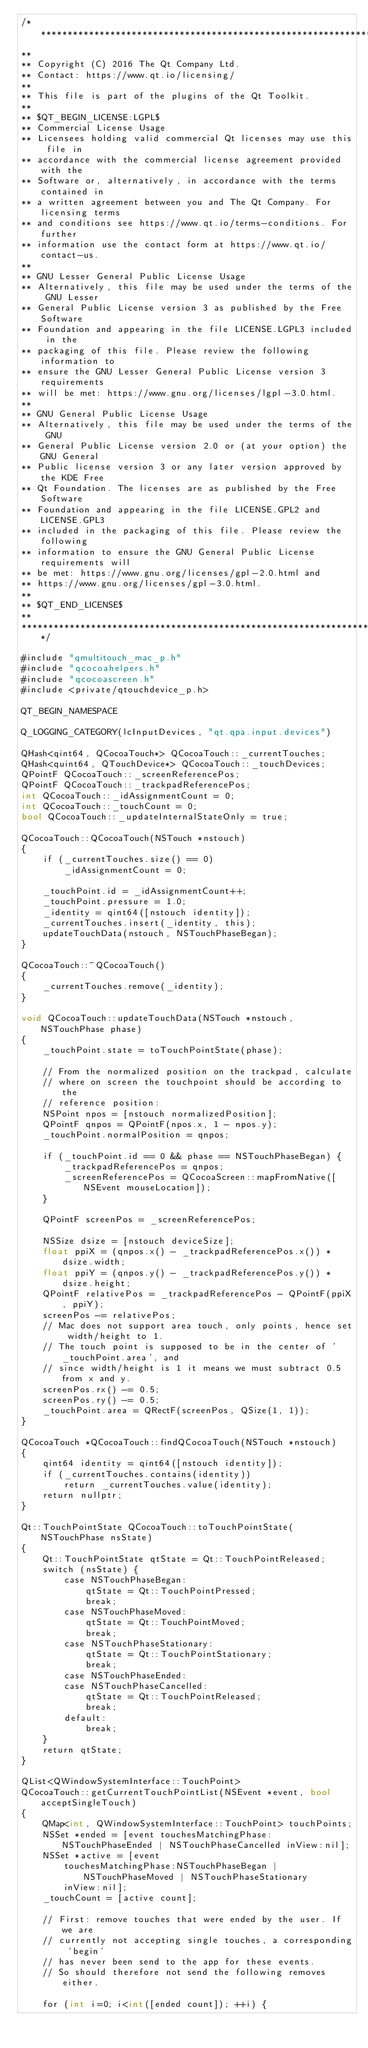<code> <loc_0><loc_0><loc_500><loc_500><_ObjectiveC_>/****************************************************************************
**
** Copyright (C) 2016 The Qt Company Ltd.
** Contact: https://www.qt.io/licensing/
**
** This file is part of the plugins of the Qt Toolkit.
**
** $QT_BEGIN_LICENSE:LGPL$
** Commercial License Usage
** Licensees holding valid commercial Qt licenses may use this file in
** accordance with the commercial license agreement provided with the
** Software or, alternatively, in accordance with the terms contained in
** a written agreement between you and The Qt Company. For licensing terms
** and conditions see https://www.qt.io/terms-conditions. For further
** information use the contact form at https://www.qt.io/contact-us.
**
** GNU Lesser General Public License Usage
** Alternatively, this file may be used under the terms of the GNU Lesser
** General Public License version 3 as published by the Free Software
** Foundation and appearing in the file LICENSE.LGPL3 included in the
** packaging of this file. Please review the following information to
** ensure the GNU Lesser General Public License version 3 requirements
** will be met: https://www.gnu.org/licenses/lgpl-3.0.html.
**
** GNU General Public License Usage
** Alternatively, this file may be used under the terms of the GNU
** General Public License version 2.0 or (at your option) the GNU General
** Public license version 3 or any later version approved by the KDE Free
** Qt Foundation. The licenses are as published by the Free Software
** Foundation and appearing in the file LICENSE.GPL2 and LICENSE.GPL3
** included in the packaging of this file. Please review the following
** information to ensure the GNU General Public License requirements will
** be met: https://www.gnu.org/licenses/gpl-2.0.html and
** https://www.gnu.org/licenses/gpl-3.0.html.
**
** $QT_END_LICENSE$
**
****************************************************************************/

#include "qmultitouch_mac_p.h"
#include "qcocoahelpers.h"
#include "qcocoascreen.h"
#include <private/qtouchdevice_p.h>

QT_BEGIN_NAMESPACE

Q_LOGGING_CATEGORY(lcInputDevices, "qt.qpa.input.devices")

QHash<qint64, QCocoaTouch*> QCocoaTouch::_currentTouches;
QHash<quint64, QTouchDevice*> QCocoaTouch::_touchDevices;
QPointF QCocoaTouch::_screenReferencePos;
QPointF QCocoaTouch::_trackpadReferencePos;
int QCocoaTouch::_idAssignmentCount = 0;
int QCocoaTouch::_touchCount = 0;
bool QCocoaTouch::_updateInternalStateOnly = true;

QCocoaTouch::QCocoaTouch(NSTouch *nstouch)
{
    if (_currentTouches.size() == 0)
        _idAssignmentCount = 0;

    _touchPoint.id = _idAssignmentCount++;
    _touchPoint.pressure = 1.0;
    _identity = qint64([nstouch identity]);
    _currentTouches.insert(_identity, this);
    updateTouchData(nstouch, NSTouchPhaseBegan);
}

QCocoaTouch::~QCocoaTouch()
{
    _currentTouches.remove(_identity);
}

void QCocoaTouch::updateTouchData(NSTouch *nstouch, NSTouchPhase phase)
{
    _touchPoint.state = toTouchPointState(phase);

    // From the normalized position on the trackpad, calculate
    // where on screen the touchpoint should be according to the
    // reference position:
    NSPoint npos = [nstouch normalizedPosition];
    QPointF qnpos = QPointF(npos.x, 1 - npos.y);
    _touchPoint.normalPosition = qnpos;

    if (_touchPoint.id == 0 && phase == NSTouchPhaseBegan) {
        _trackpadReferencePos = qnpos;
        _screenReferencePos = QCocoaScreen::mapFromNative([NSEvent mouseLocation]);
    }

    QPointF screenPos = _screenReferencePos;

    NSSize dsize = [nstouch deviceSize];
    float ppiX = (qnpos.x() - _trackpadReferencePos.x()) * dsize.width;
    float ppiY = (qnpos.y() - _trackpadReferencePos.y()) * dsize.height;
    QPointF relativePos = _trackpadReferencePos - QPointF(ppiX, ppiY);
    screenPos -= relativePos;
    // Mac does not support area touch, only points, hence set width/height to 1.
    // The touch point is supposed to be in the center of '_touchPoint.area', and
    // since width/height is 1 it means we must subtract 0.5 from x and y.
    screenPos.rx() -= 0.5;
    screenPos.ry() -= 0.5;
    _touchPoint.area = QRectF(screenPos, QSize(1, 1));
}

QCocoaTouch *QCocoaTouch::findQCocoaTouch(NSTouch *nstouch)
{
    qint64 identity = qint64([nstouch identity]);
    if (_currentTouches.contains(identity))
        return _currentTouches.value(identity);
    return nullptr;
}

Qt::TouchPointState QCocoaTouch::toTouchPointState(NSTouchPhase nsState)
{
    Qt::TouchPointState qtState = Qt::TouchPointReleased;
    switch (nsState) {
        case NSTouchPhaseBegan:
            qtState = Qt::TouchPointPressed;
            break;
        case NSTouchPhaseMoved:
            qtState = Qt::TouchPointMoved;
            break;
        case NSTouchPhaseStationary:
            qtState = Qt::TouchPointStationary;
            break;
        case NSTouchPhaseEnded:
        case NSTouchPhaseCancelled:
            qtState = Qt::TouchPointReleased;
            break;
        default:
            break;
    }
    return qtState;
}

QList<QWindowSystemInterface::TouchPoint>
QCocoaTouch::getCurrentTouchPointList(NSEvent *event, bool acceptSingleTouch)
{
    QMap<int, QWindowSystemInterface::TouchPoint> touchPoints;
    NSSet *ended = [event touchesMatchingPhase:NSTouchPhaseEnded | NSTouchPhaseCancelled inView:nil];
    NSSet *active = [event
        touchesMatchingPhase:NSTouchPhaseBegan | NSTouchPhaseMoved | NSTouchPhaseStationary
        inView:nil];
    _touchCount = [active count];

    // First: remove touches that were ended by the user. If we are
    // currently not accepting single touches, a corresponding 'begin'
    // has never been send to the app for these events.
    // So should therefore not send the following removes either.

    for (int i=0; i<int([ended count]); ++i) {</code> 